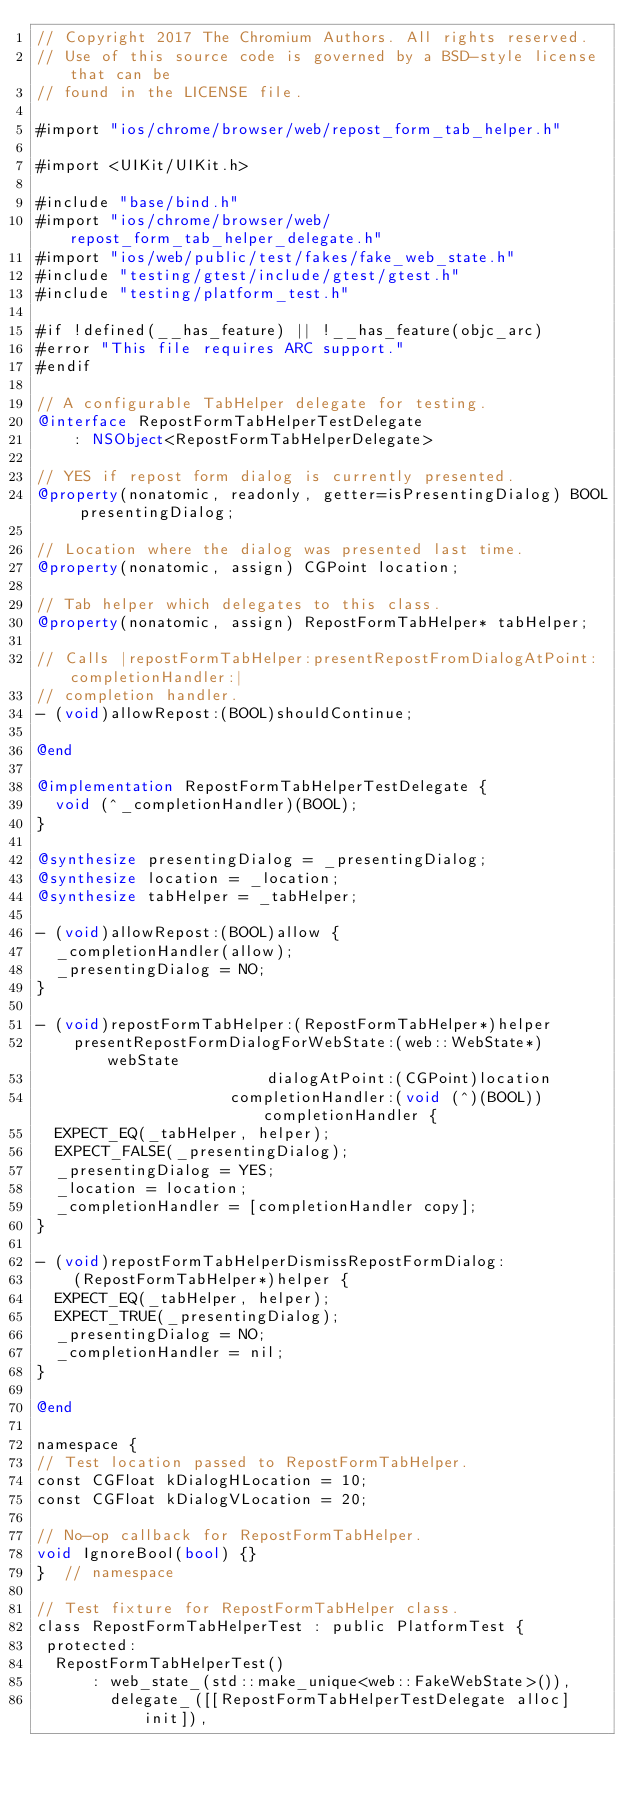<code> <loc_0><loc_0><loc_500><loc_500><_ObjectiveC_>// Copyright 2017 The Chromium Authors. All rights reserved.
// Use of this source code is governed by a BSD-style license that can be
// found in the LICENSE file.

#import "ios/chrome/browser/web/repost_form_tab_helper.h"

#import <UIKit/UIKit.h>

#include "base/bind.h"
#import "ios/chrome/browser/web/repost_form_tab_helper_delegate.h"
#import "ios/web/public/test/fakes/fake_web_state.h"
#include "testing/gtest/include/gtest/gtest.h"
#include "testing/platform_test.h"

#if !defined(__has_feature) || !__has_feature(objc_arc)
#error "This file requires ARC support."
#endif

// A configurable TabHelper delegate for testing.
@interface RepostFormTabHelperTestDelegate
    : NSObject<RepostFormTabHelperDelegate>

// YES if repost form dialog is currently presented.
@property(nonatomic, readonly, getter=isPresentingDialog) BOOL presentingDialog;

// Location where the dialog was presented last time.
@property(nonatomic, assign) CGPoint location;

// Tab helper which delegates to this class.
@property(nonatomic, assign) RepostFormTabHelper* tabHelper;

// Calls |repostFormTabHelper:presentRepostFromDialogAtPoint:completionHandler:|
// completion handler.
- (void)allowRepost:(BOOL)shouldContinue;

@end

@implementation RepostFormTabHelperTestDelegate {
  void (^_completionHandler)(BOOL);
}

@synthesize presentingDialog = _presentingDialog;
@synthesize location = _location;
@synthesize tabHelper = _tabHelper;

- (void)allowRepost:(BOOL)allow {
  _completionHandler(allow);
  _presentingDialog = NO;
}

- (void)repostFormTabHelper:(RepostFormTabHelper*)helper
    presentRepostFormDialogForWebState:(web::WebState*)webState
                         dialogAtPoint:(CGPoint)location
                     completionHandler:(void (^)(BOOL))completionHandler {
  EXPECT_EQ(_tabHelper, helper);
  EXPECT_FALSE(_presentingDialog);
  _presentingDialog = YES;
  _location = location;
  _completionHandler = [completionHandler copy];
}

- (void)repostFormTabHelperDismissRepostFormDialog:
    (RepostFormTabHelper*)helper {
  EXPECT_EQ(_tabHelper, helper);
  EXPECT_TRUE(_presentingDialog);
  _presentingDialog = NO;
  _completionHandler = nil;
}

@end

namespace {
// Test location passed to RepostFormTabHelper.
const CGFloat kDialogHLocation = 10;
const CGFloat kDialogVLocation = 20;

// No-op callback for RepostFormTabHelper.
void IgnoreBool(bool) {}
}  // namespace

// Test fixture for RepostFormTabHelper class.
class RepostFormTabHelperTest : public PlatformTest {
 protected:
  RepostFormTabHelperTest()
      : web_state_(std::make_unique<web::FakeWebState>()),
        delegate_([[RepostFormTabHelperTestDelegate alloc] init]),</code> 